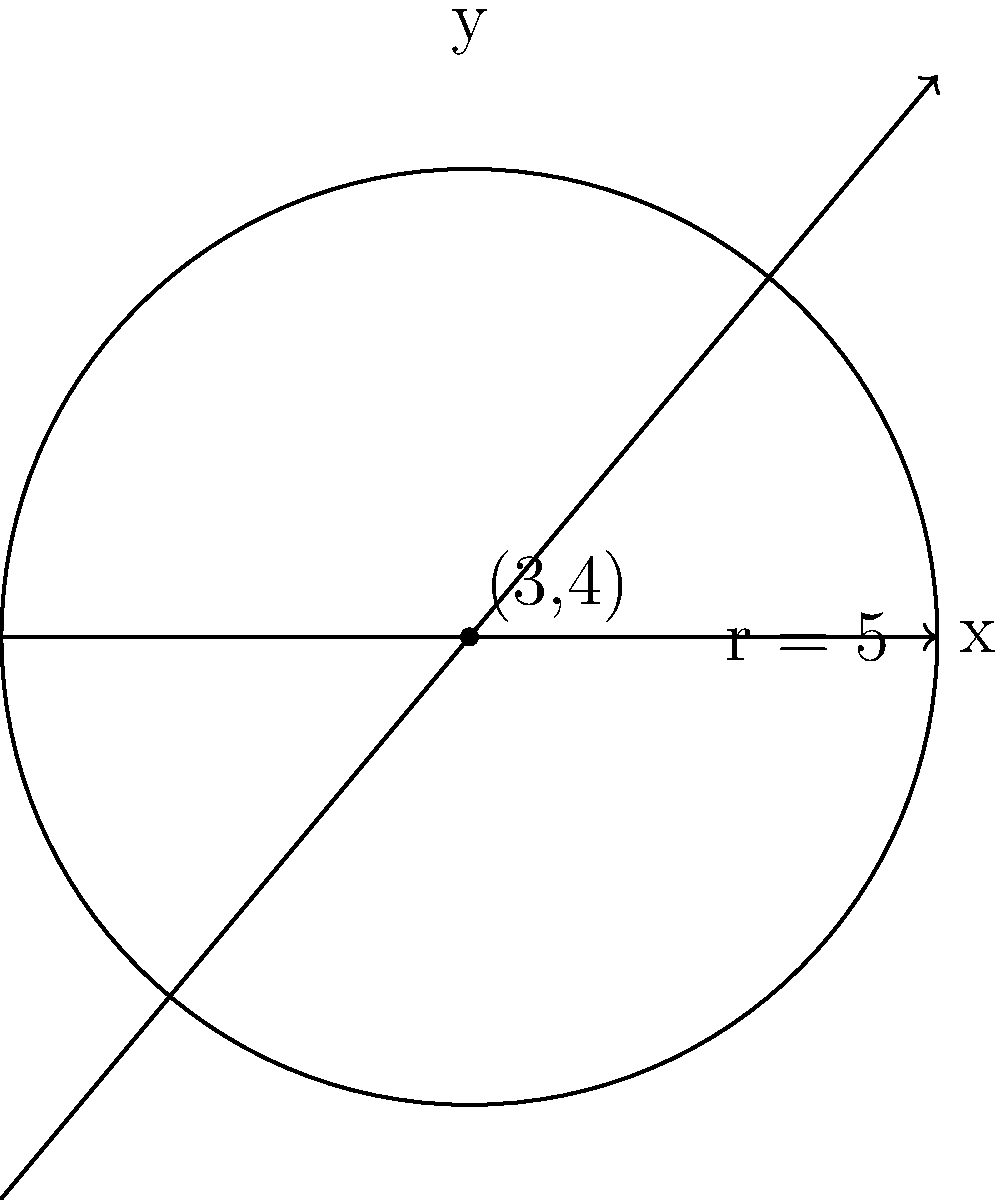A circular gathering space for community events is planned on a coordinate system. The center of the circle is at (3,4) with a radius of 5 units. What is the perimeter of this circular space? To find the perimeter of a circular space, we need to calculate its circumference. The formula for the circumference of a circle is:

$$C = 2\pi r$$

Where:
- $C$ is the circumference (perimeter)
- $\pi$ is pi (approximately 3.14159)
- $r$ is the radius of the circle

Given:
- The center of the circle is at (3,4), but this information is not needed for the circumference calculation.
- The radius of the circle is 5 units.

Let's calculate:

$$\begin{align}
C &= 2\pi r \\
&= 2 \times \pi \times 5 \\
&= 10\pi \\
&\approx 31.4159 \text{ units}
\end{align}$$

Therefore, the perimeter of the circular gathering space is $10\pi$ or approximately 31.4159 units.
Answer: $10\pi$ units 